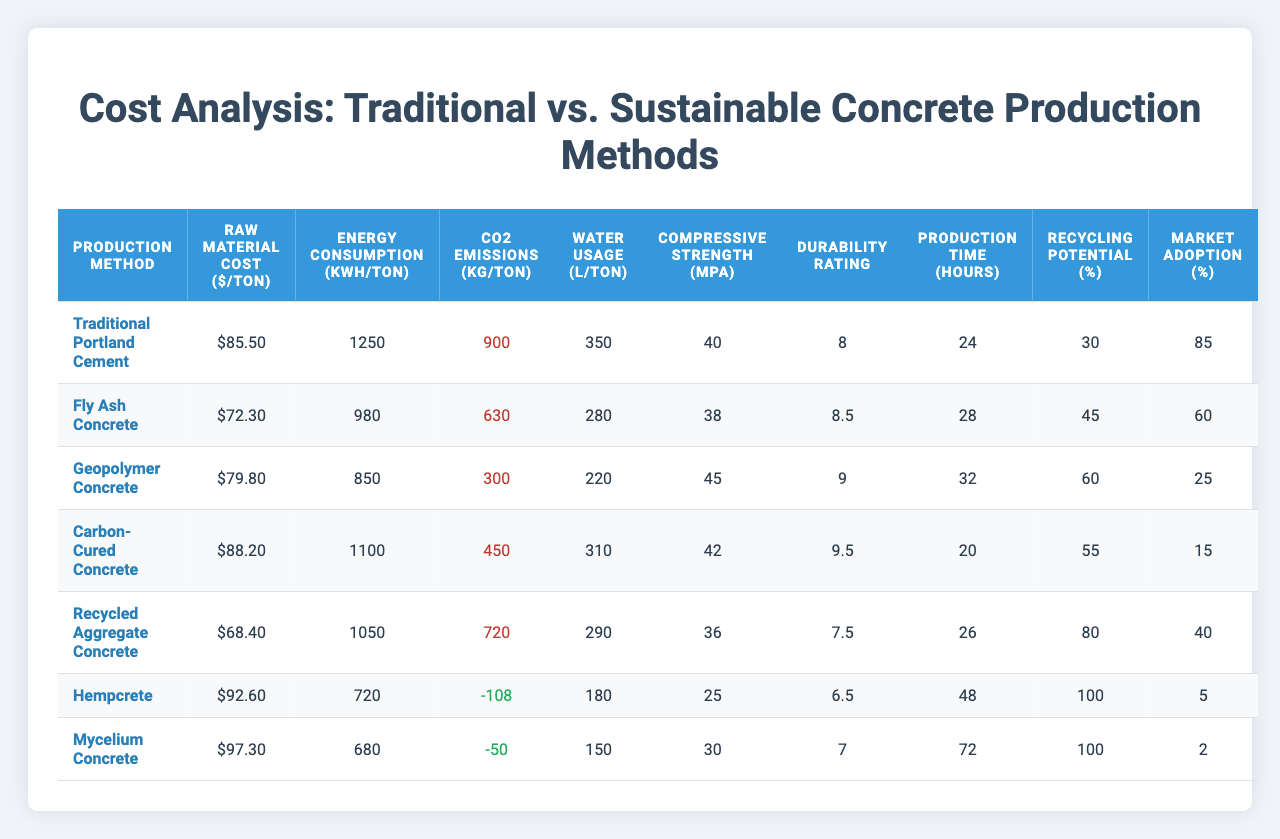What is the raw material cost of Geopolymer Concrete? According to the table, the raw material cost for Geopolymer Concrete is indicated as $79.80 per ton.
Answer: $79.80 Which concrete production method has the lowest energy consumption? In the energy consumption column, the value for Hempcrete is the lowest at 680 kWh/ton.
Answer: Hempcrete Is the CO2 emissions from Carbon-Cured Concrete positive or negative? The table shows CO2 emissions for Carbon-Cured Concrete as 450 kg/ton, which is a positive value.
Answer: Positive What is the average water usage across all methods? To find the average, sum the water usage values: 350 + 280 + 220 + 310 + 290 + 180 + 150 = 1980 L. There are 7 methods, so the average is 1980/7 = 282.86 L.
Answer: 282.86 L Which concrete method has the highest durability rating? The durability rating column indicates that Carbon-Cured Concrete has the highest rating at 9.5.
Answer: 9.5 How much more compressive strength does Geopolymer Concrete have compared to Recycled Aggregate Concrete? The compressive strength for Geopolymer Concrete is 45 MPa, and for Recycled Aggregate Concrete, it is 36 MPa. The difference is 45 - 36 = 9 MPa.
Answer: 9 MPa Is the water usage for Fly Ash Concrete higher than that for Mycelium Concrete? The table lists Fly Ash Concrete at 280 L/ton and Mycelium Concrete at 150 L/ton. Since 280 > 150, Fly Ash Concrete has higher water usage.
Answer: Yes What is the overall market adoption percentage for all sustainable concrete methods combined? The market adoption values for sustainable methods are: Fly Ash Concrete (60), Geopolymer Concrete (25), Carbon-Cured Concrete (15), Recycled Aggregate Concrete (40), Hempcrete (5), and Mycelium Concrete (2). The total is 60 + 25 + 15 + 40 + 5 + 2 = 147. There are 6 methods, so the average is 147/6 = 24.5%.
Answer: 24.5% Which production method has the highest recycling potential? Looking at the recycling potential column, Recycled Aggregate Concrete shows the highest recycling potential at 80%.
Answer: 80% Is the average raw material cost of traditional methods lower than that of sustainable methods? The average raw material cost for traditional methods (Traditional Portland Cement, Fly Ash Concrete) is (85.50 + 72.30) / 2 = 78.90. For sustainable methods (all others), it's (79.80 + 88.20 + 68.40 + 92.60 + 97.30) / 5 = 85.44. Since 78.90 < 85.44, the average of traditional is lower.
Answer: Yes 